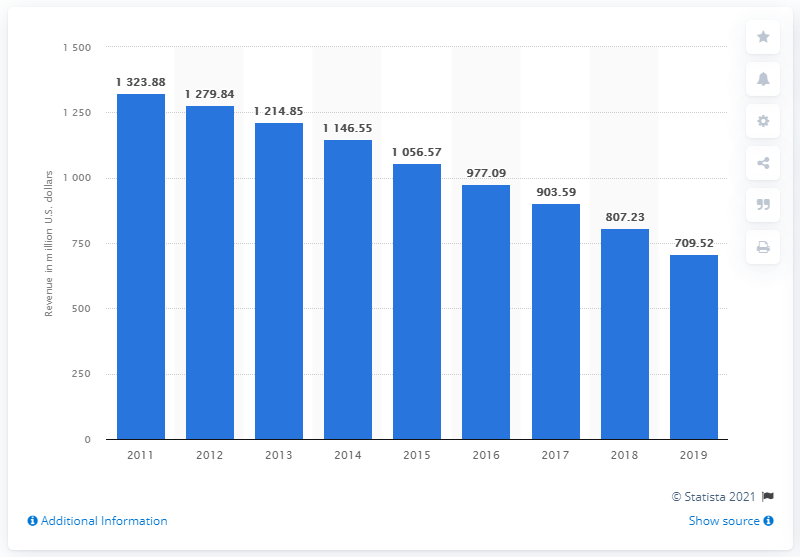Identify some key points in this picture. The McClatchy Company generated $709.52 million in revenue in 2019. 